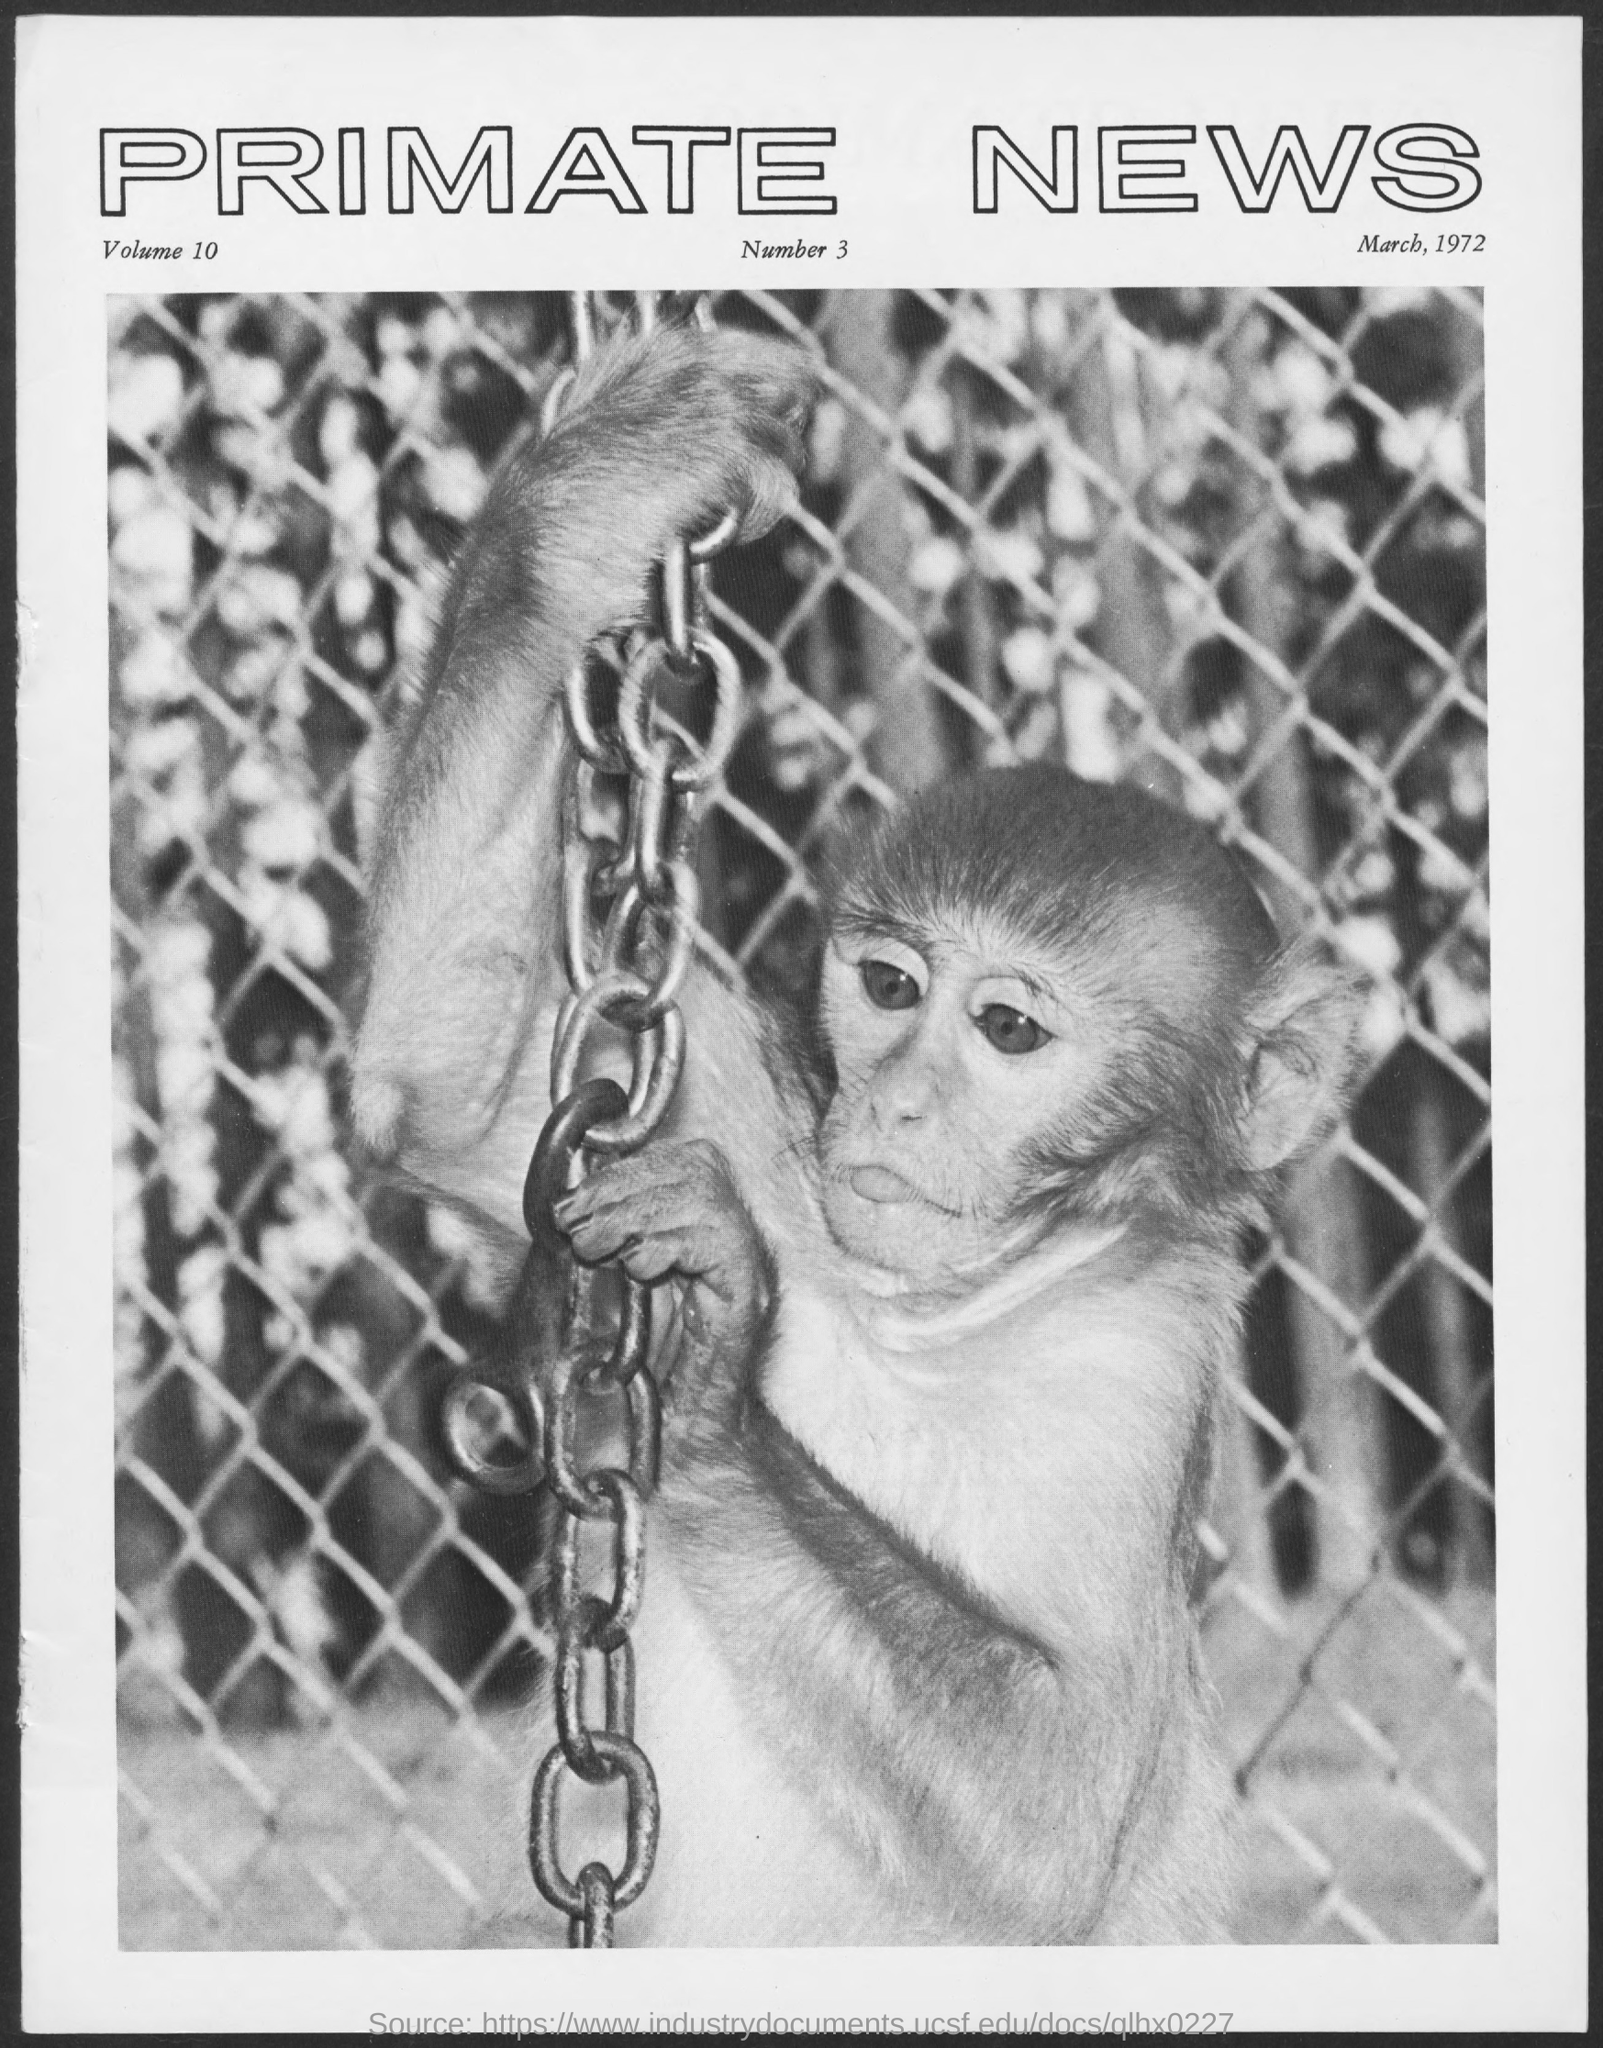Point out several critical features in this image. The document indicates that the date is March, 1972. The volume is 10... The title of the document is 'Primate News.' 